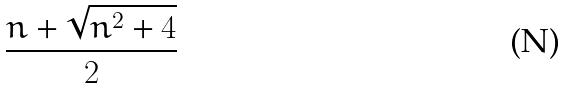Convert formula to latex. <formula><loc_0><loc_0><loc_500><loc_500>\frac { n + \sqrt { n ^ { 2 } + 4 } } { 2 }</formula> 